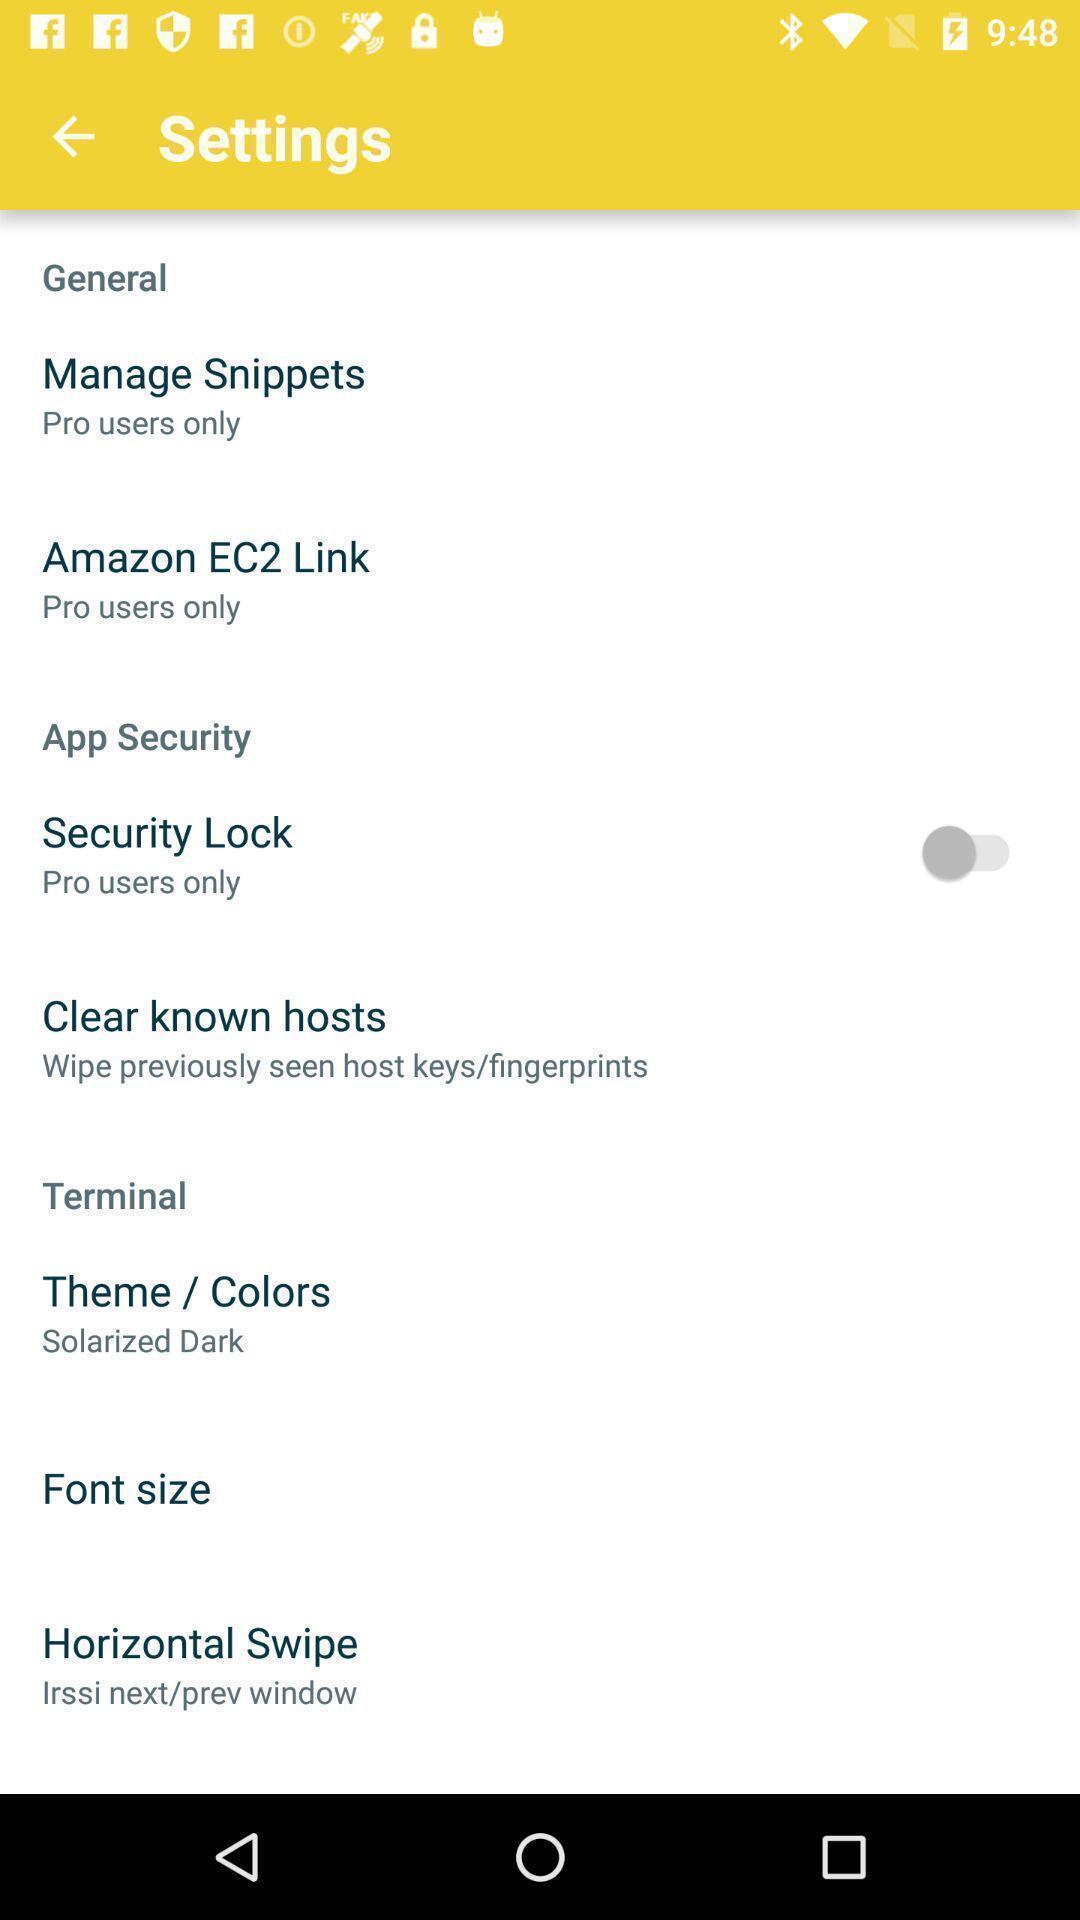Describe this image in words. Page shows the various general settings options on support app. 